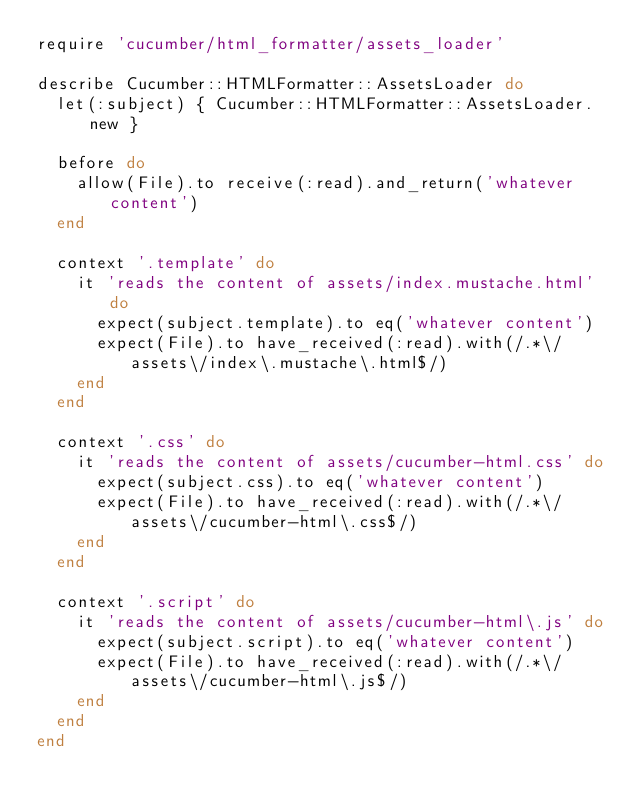Convert code to text. <code><loc_0><loc_0><loc_500><loc_500><_Ruby_>require 'cucumber/html_formatter/assets_loader'

describe Cucumber::HTMLFormatter::AssetsLoader do
  let(:subject) { Cucumber::HTMLFormatter::AssetsLoader.new }

  before do
    allow(File).to receive(:read).and_return('whatever content')
  end

  context '.template' do
    it 'reads the content of assets/index.mustache.html' do
      expect(subject.template).to eq('whatever content')
      expect(File).to have_received(:read).with(/.*\/assets\/index\.mustache\.html$/)
    end
  end

  context '.css' do
    it 'reads the content of assets/cucumber-html.css' do
      expect(subject.css).to eq('whatever content')
      expect(File).to have_received(:read).with(/.*\/assets\/cucumber-html\.css$/)
    end
  end

  context '.script' do
    it 'reads the content of assets/cucumber-html\.js' do
      expect(subject.script).to eq('whatever content')
      expect(File).to have_received(:read).with(/.*\/assets\/cucumber-html\.js$/)
    end
  end
end</code> 